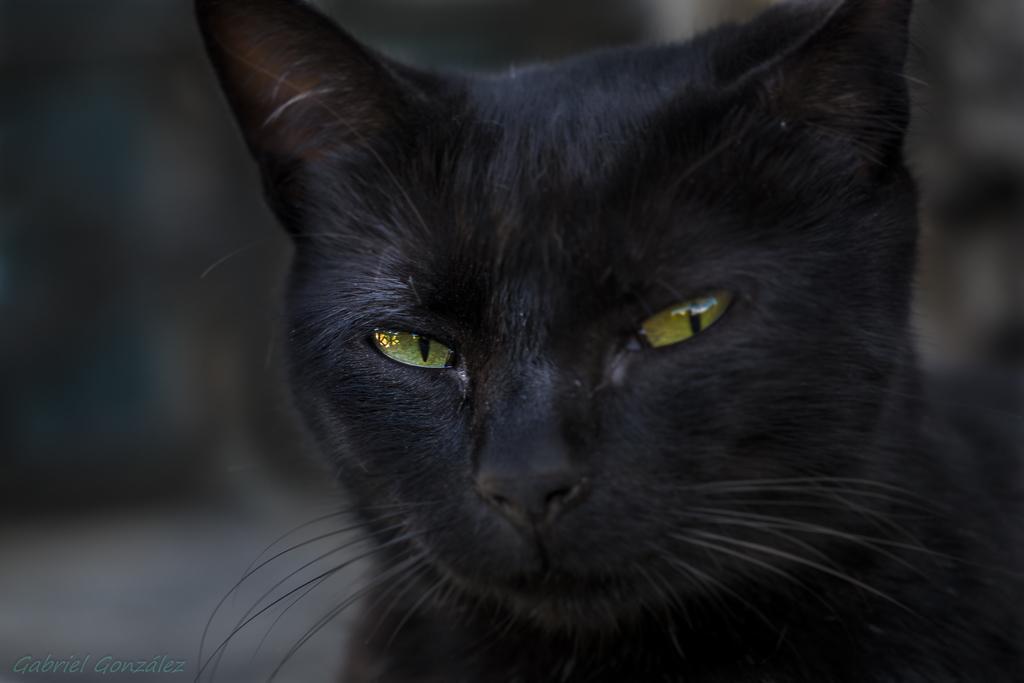How would you summarize this image in a sentence or two? In this image, I can see a black cat. The background looks blue. At the bottom left corner of the image, I can see the watermark. 